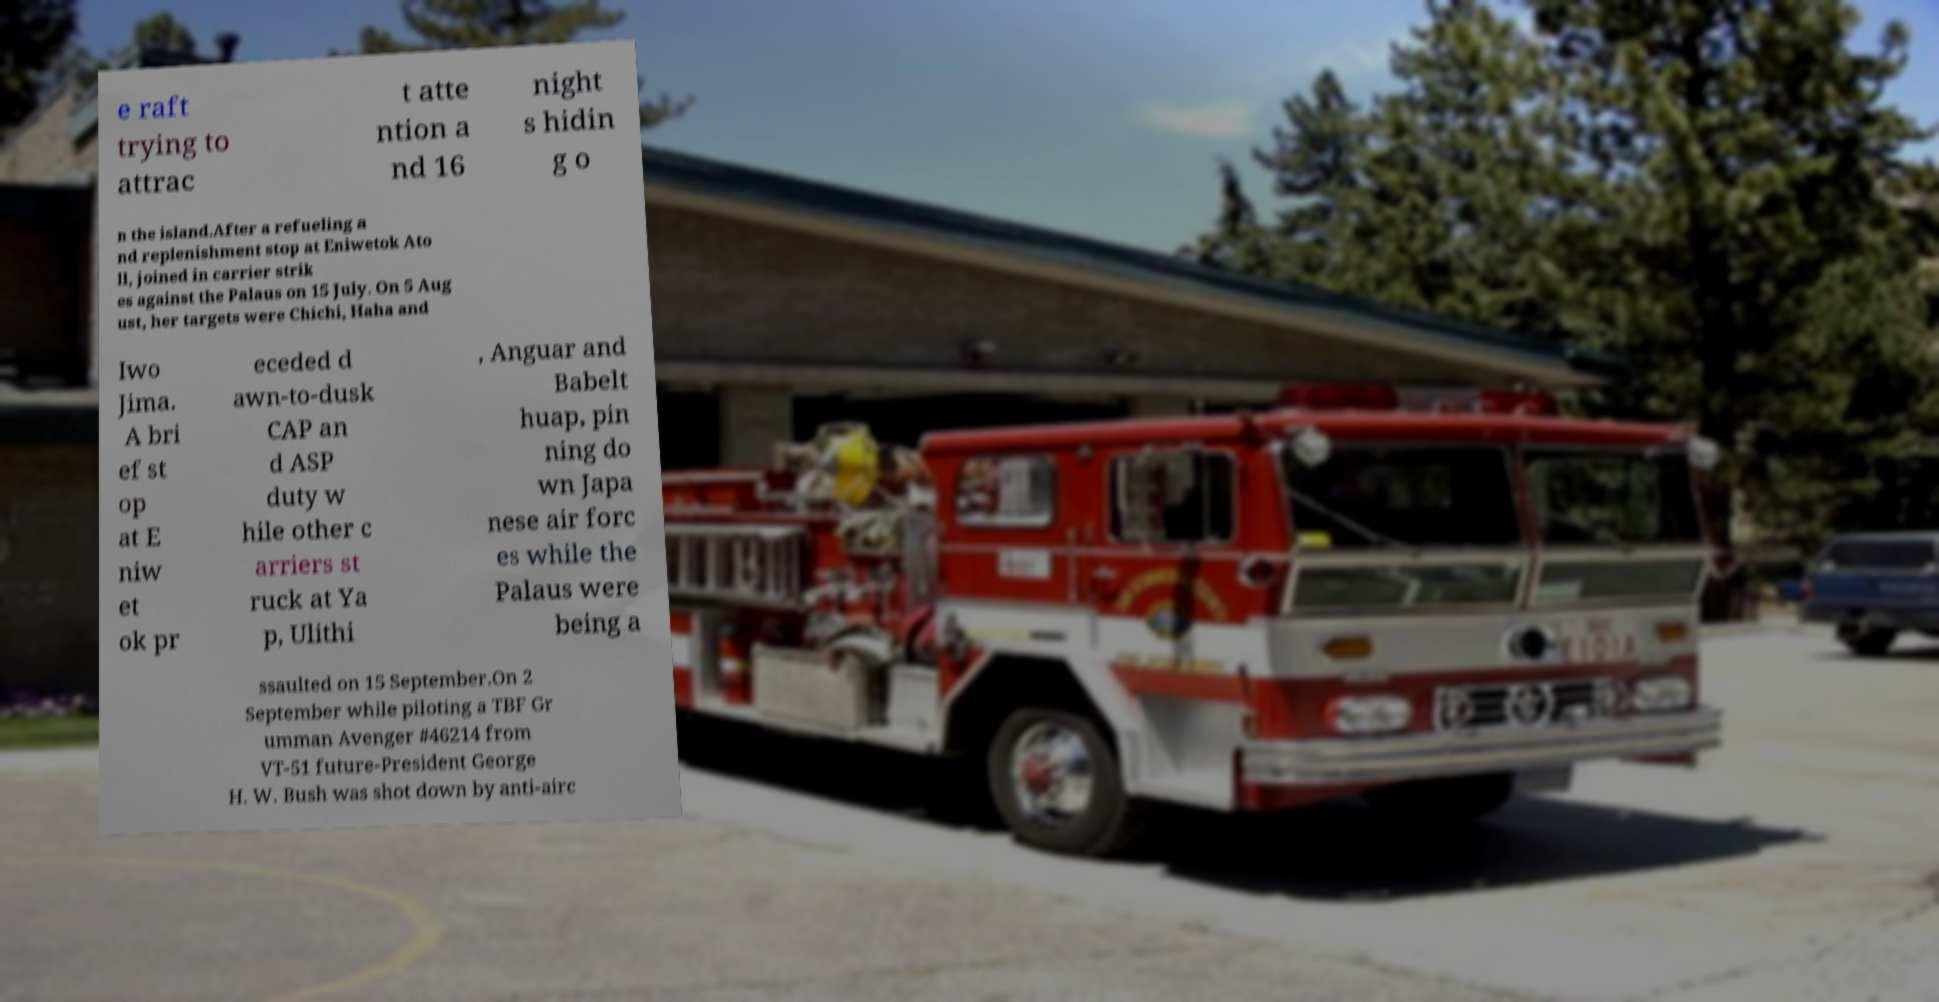Could you extract and type out the text from this image? e raft trying to attrac t atte ntion a nd 16 night s hidin g o n the island.After a refueling a nd replenishment stop at Eniwetok Ato ll, joined in carrier strik es against the Palaus on 15 July. On 5 Aug ust, her targets were Chichi, Haha and Iwo Jima. A bri ef st op at E niw et ok pr eceded d awn-to-dusk CAP an d ASP duty w hile other c arriers st ruck at Ya p, Ulithi , Anguar and Babelt huap, pin ning do wn Japa nese air forc es while the Palaus were being a ssaulted on 15 September.On 2 September while piloting a TBF Gr umman Avenger #46214 from VT-51 future-President George H. W. Bush was shot down by anti-airc 